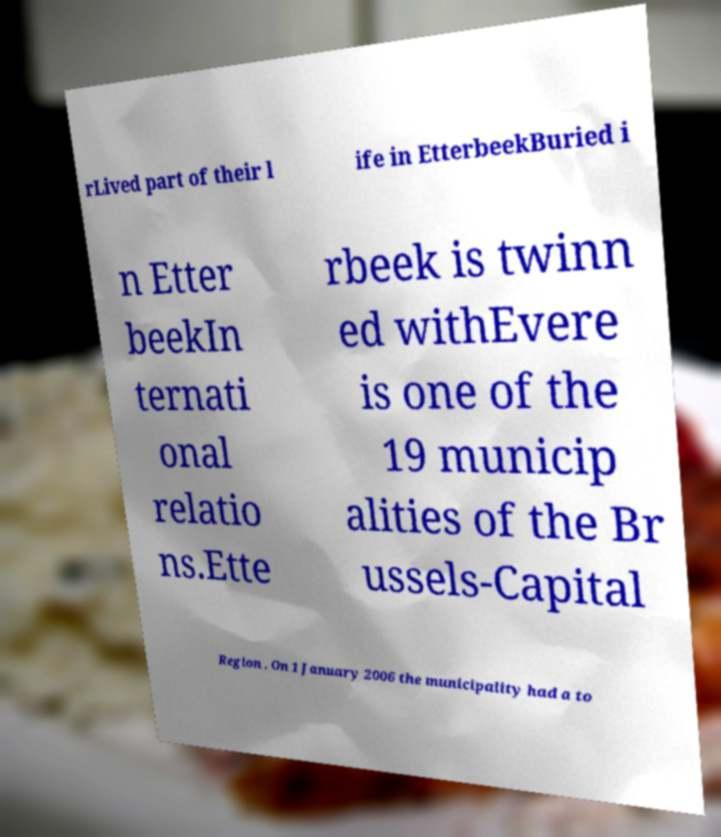Could you extract and type out the text from this image? rLived part of their l ife in EtterbeekBuried i n Etter beekIn ternati onal relatio ns.Ette rbeek is twinn ed withEvere is one of the 19 municip alities of the Br ussels-Capital Region . On 1 January 2006 the municipality had a to 